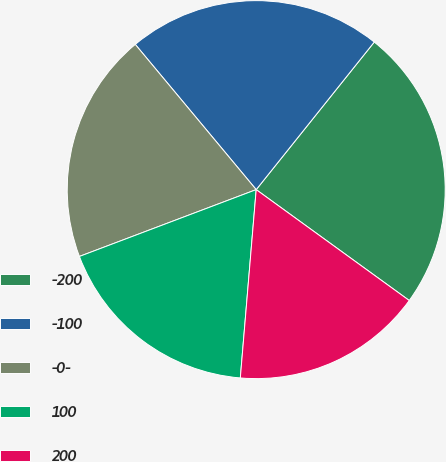Convert chart. <chart><loc_0><loc_0><loc_500><loc_500><pie_chart><fcel>-200<fcel>-100<fcel>-0-<fcel>100<fcel>200<nl><fcel>24.24%<fcel>21.79%<fcel>19.7%<fcel>17.91%<fcel>16.36%<nl></chart> 